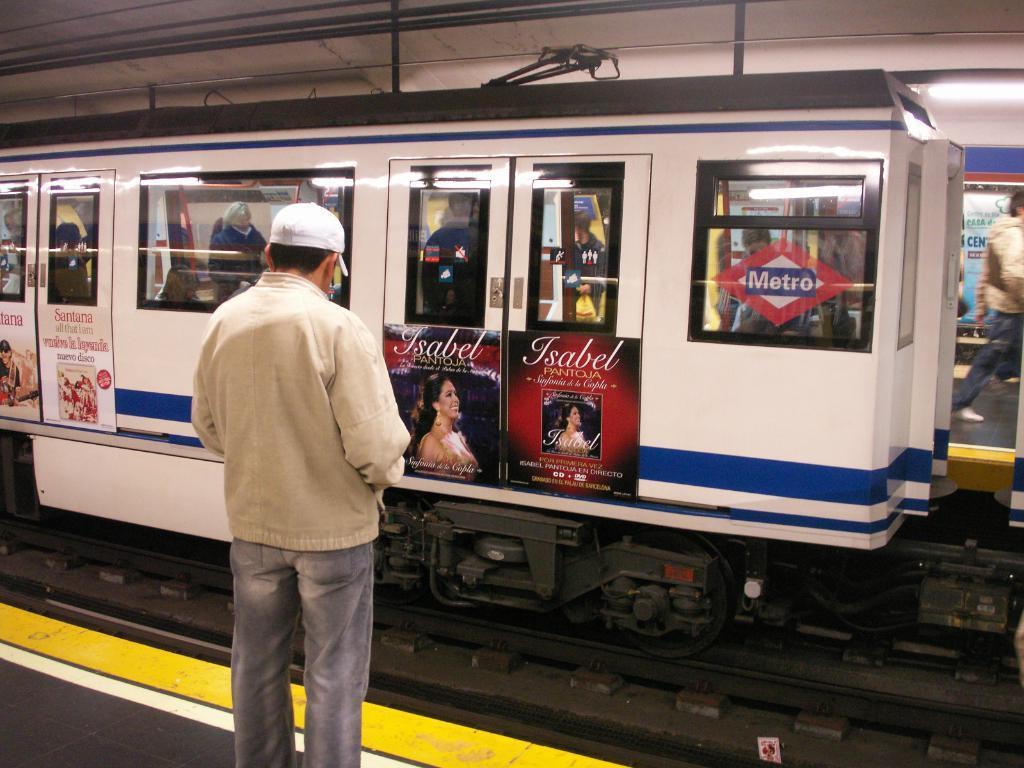How would you summarize this image in a sentence or two? In this picture there is a man who is wearing cap, jacket and jeans. He is standing on the platform. In front of him there is a white color train on the railway track. Inside the train I can see many peoples were standing and sitting. On the doors I can see the posters. Behind the train I can see some people were standing on the other platform. In the top right corner there is a tube light which is placed on the roof of a shed. 